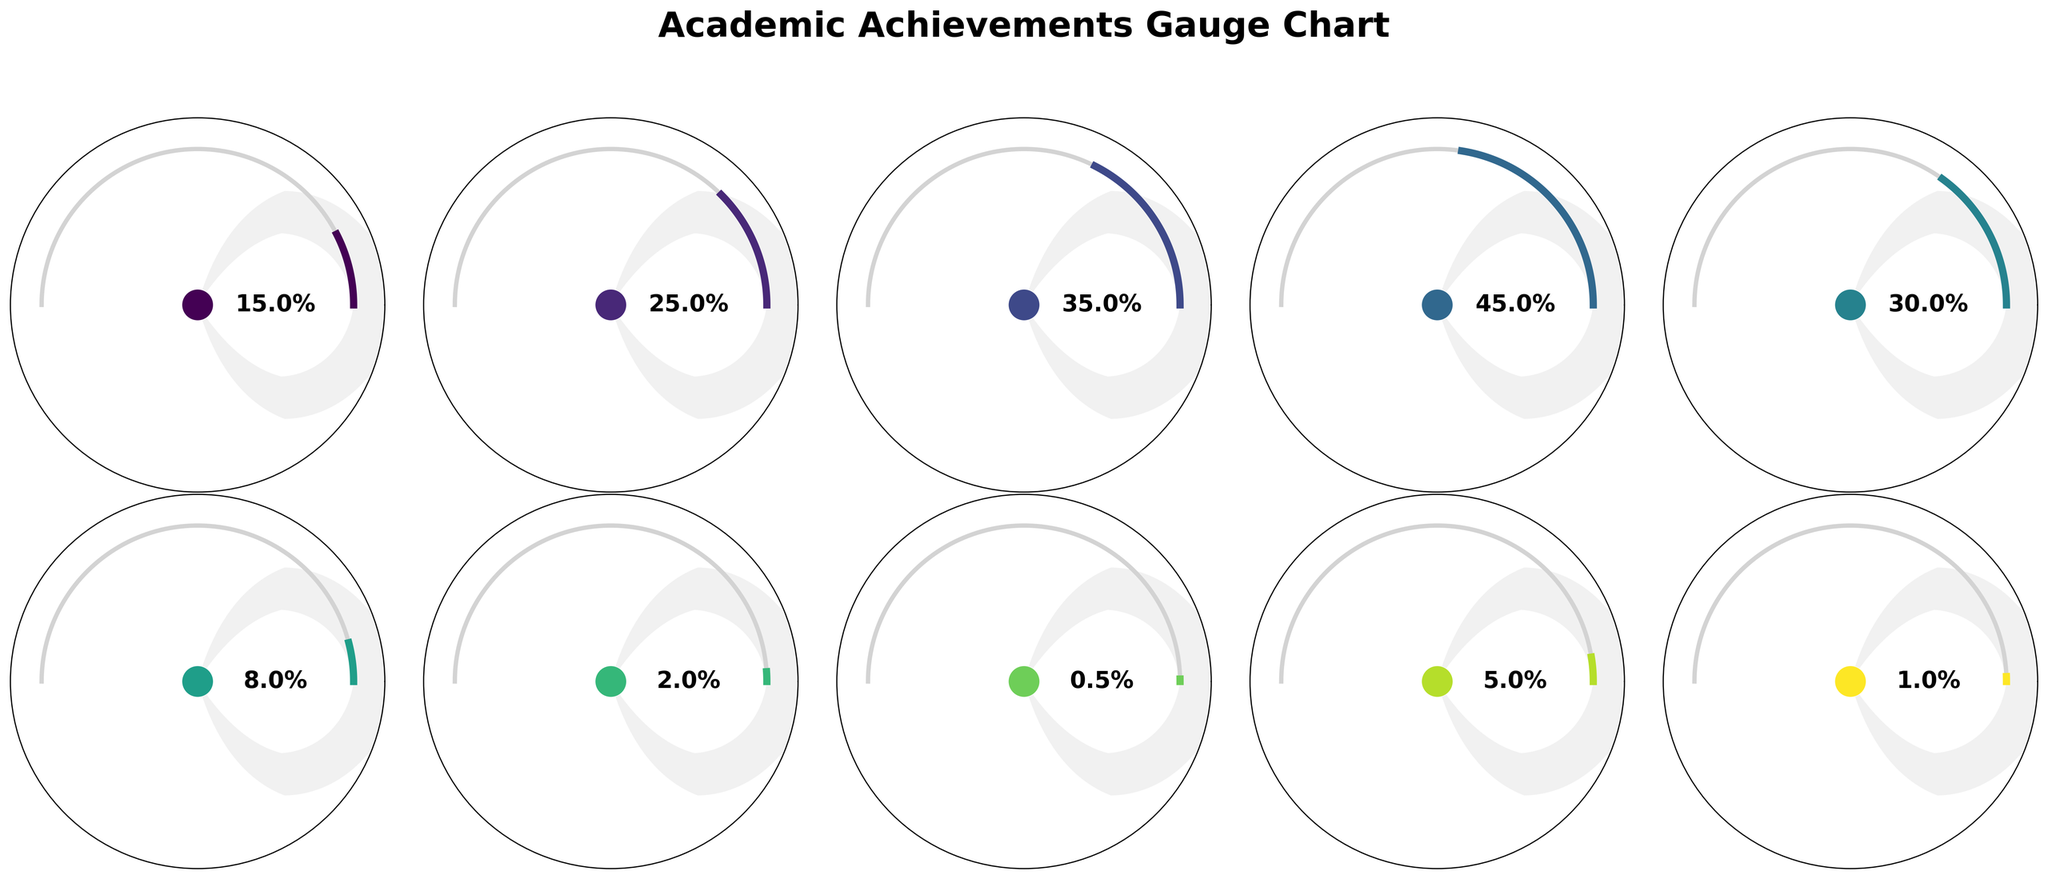What is the title of the figure? The title of the figure is located at the top, and it reads "Academic Achievements Gauge Chart."
Answer: Academic Achievements Gauge Chart Which category has the highest percentage on the gauge charts? By looking at the gauge charts, the "Dean's List" category has the highest percentage, shown as 45%.
Answer: Dean's List How many categories show a percentage greater than 30%? According to the gauge charts, the categories "Cum Laude" (35%), "Departmental Honors" (30%), "Magna Cum Laude" (25%), and "Dean's List" (45%) each have percentages greater than 30%.
Answer: Four Which category has the smallest percentage, and what is this percentage? The "Rhodes Scholars" category displays the smallest percentage, which is 0.5%.
Answer: Rhodes Scholars, 0.5% What is the combined percentage of students receiving the "Fulbright Scholars" and "Presidential Scholars" awards? The gauge charts show "Fulbright Scholars" at 2% and "Presidential Scholars" at 1%. Summing these up gives 2% + 1% = 3%.
Answer: 3% How does the percentage of "Cum Laude" compare to "Magna Cum Laude"? The gauge charts reveal that "Cum Laude" has 35%, while "Magna Cum Laude" has 25%, indicating "Cum Laude" has a greater percentage.
Answer: Cum Laude is greater Which category has a percentage exactly twice that of "National Merit Scholars"? The gauge charts show that the "Dean's List" has a percentage of 45%, which is nine times not equal to National Merit Scholars at 5%. There is no category exactly twice the percentage of "National Merit Scholars".
Answer: None What is the average percentage of the "Summa Cum Laude," "Magna Cum Laude," and "Cum Laude" categories? Summing the percentages for "Summa Cum Laude" (15%), "Magna Cum Laude" (25%), and "Cum Laude" (35%) results in 15% + 25% + 35% = 75%. Dividing by the number of categories (3) gives an average of 75% / 3 = 25%.
Answer: 25% Is the percentage of "Phi Beta Kappa" greater than that of "Presidential Scholars"? The gauge charts show "Phi Beta Kappa" at 8% and "Presidential Scholars" at 1%. Thus, "Phi Beta Kappa" has a greater percentage.
Answer: Yes What is the visual indicator for each category on the gauge charts? Each category on the gauge charts is indicated by a gauge that partly fills a semicircle, with the percentage also numerically displayed in the middle of the gauge.
Answer: Filled semicircle with percents 